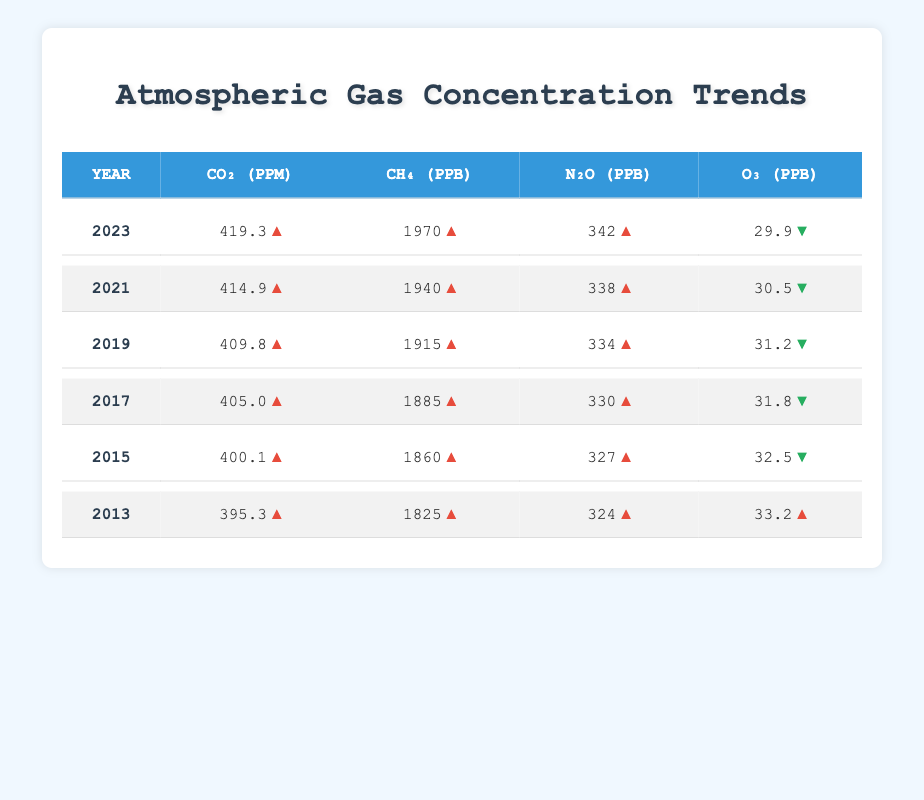What was the CO₂ concentration in 2020? The table indicates that the CO₂ concentration for the year 2020 is listed as 412.5 ppm.
Answer: 412.5 ppm Which year had the highest CH₄ concentration? By comparing the CH₄ concentrations listed for each year, the highest is 1970 ppb, recorded in 2023.
Answer: 2023 What is the difference in N₂O concentration between 2013 and 2023? For 2013, N₂O concentration is 324 ppb, and for 2023, it is 342 ppb. The difference is 342 - 324 = 18 ppb.
Answer: 18 ppb Was there an increase in O₃ concentration from 2013 to 2023? The O₃ concentration decreased from 33.2 ppb in 2013 to 29.9 ppb in 2023, indicating a decrease overall.
Answer: No What is the average CO₂ concentration over the past decade (2013 to 2023)? To find the average CO₂ concentration, we add the CO₂ values from each year (395.3 + 397.1 + 400.1 + 403.6 + 405.0 + 407.3 + 409.8 + 412.5 + 414.9 + 417.1 + 419.3) which sums to 4,509.9 ppm and then divide by the number of years, 11. This gives 4,509.9 / 11 = 409.0 ppm.
Answer: 409.0 ppm How much did the CH₄ concentration increase from 2013 to 2022? The CH₄ concentration in 2013 is 1825 ppb and in 2022 is 1955 ppb. The increase is calculated as 1955 - 1825 = 130 ppb.
Answer: 130 ppb What was the trend in O₃ concentration from 2013 to 2023? By examining the O₃ concentrations, we see a decrease from 33.2 ppb in 2013 to 29.9 ppb in 2023, showing a downward trend overall.
Answer: Decrease What is the N₂O concentration in 2021 and how does it compare to 2019? The N₂O concentration in 2021 is 338 ppb, while in 2019 it is 334 ppb. The concentration in 2021 is higher by 4 ppb.
Answer: Higher by 4 ppb In which year did the O₃ concentration experience the largest drop compared to the previous year? By reviewing the values, the largest decrease was from 30.5 ppb in 2021 to 30.2 ppb in 2022, a drop of 0.3 ppb.
Answer: 2021 to 2022 What percentage increase in CO₂ concentration occurred between 2013 and 2023? The CO₂ concentration increased from 395.3 ppm in 2013 to 419.3 ppm in 2023. The percentage increase is calculated as ((419.3 - 395.3) / 395.3) * 100 = 6.06%.
Answer: 6.06% Is it true that the CH₄ concentration in 2016 was lower than in 2014? The CH₄ concentration in 2016 is 1875 ppb, while in 2014 it was 1840 ppb. Since 1875 is higher than 1840, the statement is false.
Answer: No 